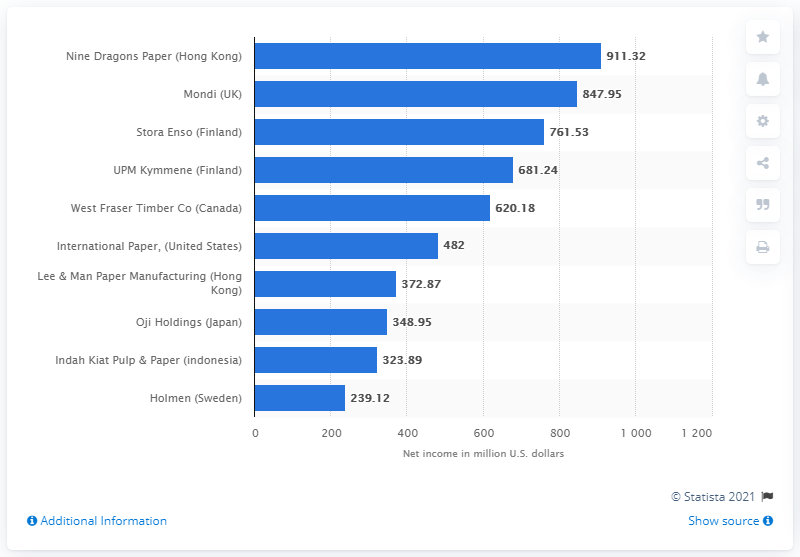Point out several critical features in this image. In 2020, Mondi's net earnings in U.S. dollars were 847.95. 